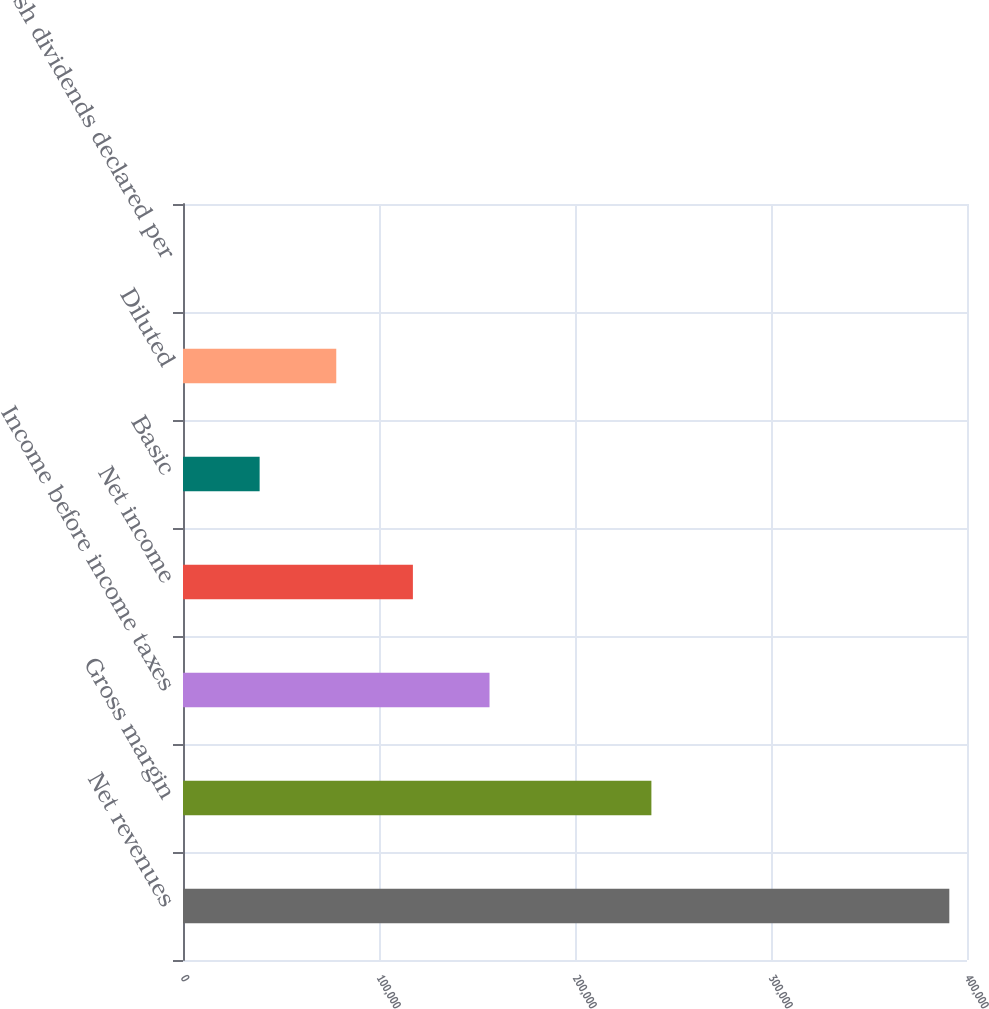Convert chart to OTSL. <chart><loc_0><loc_0><loc_500><loc_500><bar_chart><fcel>Net revenues<fcel>Gross margin<fcel>Income before income taxes<fcel>Net income<fcel>Basic<fcel>Diluted<fcel>Cash dividends declared per<nl><fcel>390977<fcel>238976<fcel>156391<fcel>117293<fcel>39097.8<fcel>78195.4<fcel>0.05<nl></chart> 